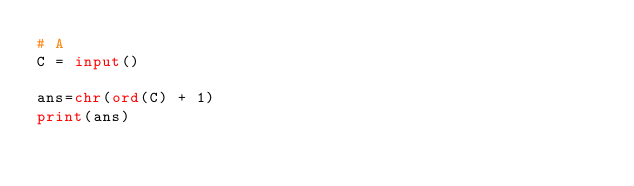<code> <loc_0><loc_0><loc_500><loc_500><_Python_># A
C = input()

ans=chr(ord(C) + 1)
print(ans)</code> 